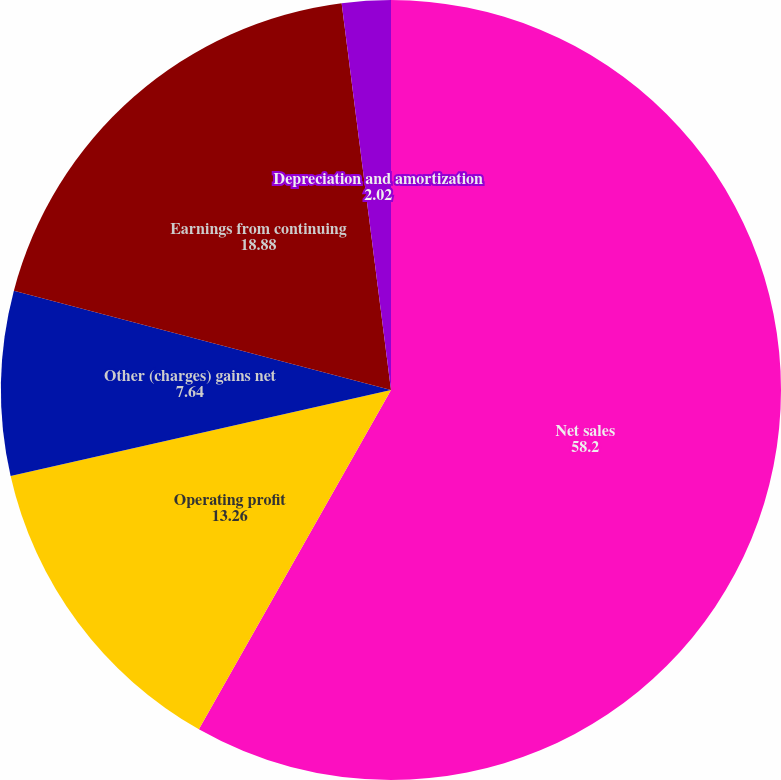Convert chart. <chart><loc_0><loc_0><loc_500><loc_500><pie_chart><fcel>Net sales<fcel>Operating profit<fcel>Other (charges) gains net<fcel>Earnings from continuing<fcel>Depreciation and amortization<nl><fcel>58.2%<fcel>13.26%<fcel>7.64%<fcel>18.88%<fcel>2.02%<nl></chart> 